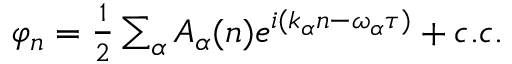<formula> <loc_0><loc_0><loc_500><loc_500>\begin{array} { r } { \varphi _ { n } = \frac { 1 } { 2 } \sum _ { \alpha } A _ { \alpha } ( n ) e ^ { i ( k _ { \alpha } n - \omega _ { \alpha } \tau ) } + c . c . } \end{array}</formula> 